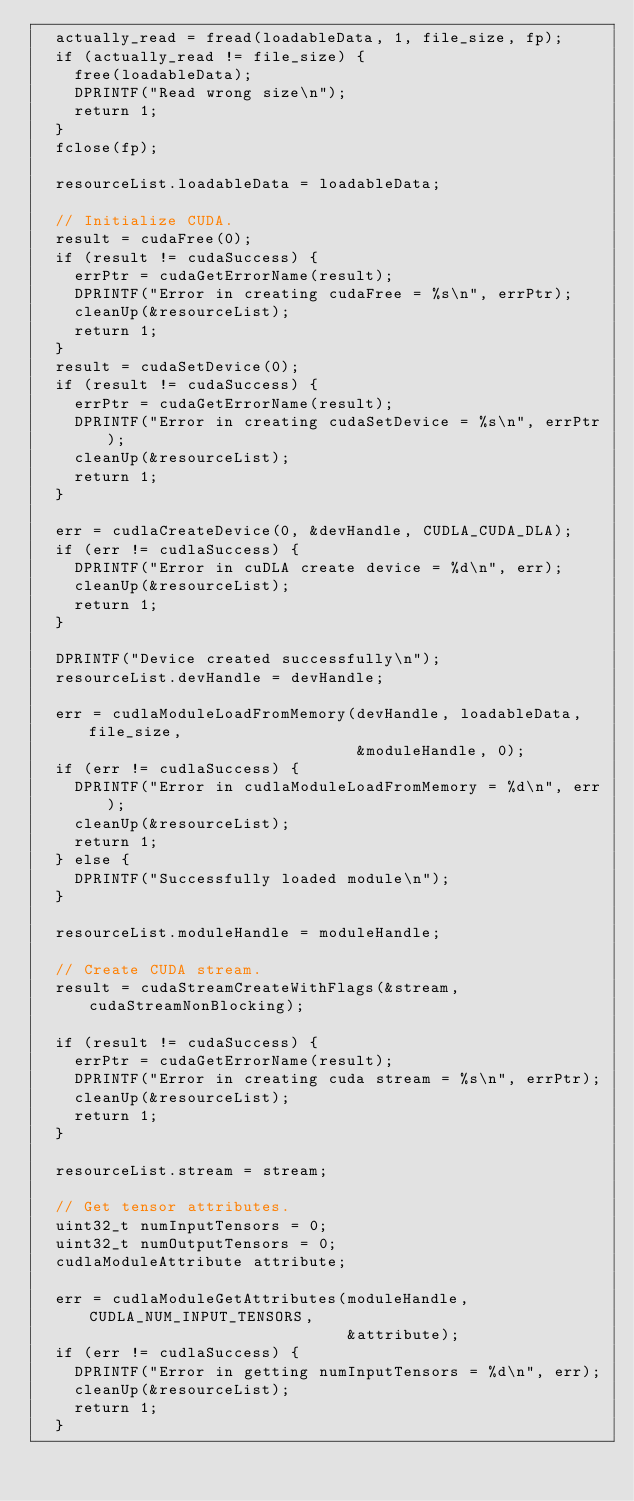<code> <loc_0><loc_0><loc_500><loc_500><_Cuda_>  actually_read = fread(loadableData, 1, file_size, fp);
  if (actually_read != file_size) {
    free(loadableData);
    DPRINTF("Read wrong size\n");
    return 1;
  }
  fclose(fp);

  resourceList.loadableData = loadableData;

  // Initialize CUDA.
  result = cudaFree(0);
  if (result != cudaSuccess) {
    errPtr = cudaGetErrorName(result);
    DPRINTF("Error in creating cudaFree = %s\n", errPtr);
    cleanUp(&resourceList);
    return 1;
  }
  result = cudaSetDevice(0);
  if (result != cudaSuccess) {
    errPtr = cudaGetErrorName(result);
    DPRINTF("Error in creating cudaSetDevice = %s\n", errPtr);
    cleanUp(&resourceList);
    return 1;
  }

  err = cudlaCreateDevice(0, &devHandle, CUDLA_CUDA_DLA);
  if (err != cudlaSuccess) {
    DPRINTF("Error in cuDLA create device = %d\n", err);
    cleanUp(&resourceList);
    return 1;
  }

  DPRINTF("Device created successfully\n");
  resourceList.devHandle = devHandle;

  err = cudlaModuleLoadFromMemory(devHandle, loadableData, file_size,
                                  &moduleHandle, 0);
  if (err != cudlaSuccess) {
    DPRINTF("Error in cudlaModuleLoadFromMemory = %d\n", err);
    cleanUp(&resourceList);
    return 1;
  } else {
    DPRINTF("Successfully loaded module\n");
  }

  resourceList.moduleHandle = moduleHandle;

  // Create CUDA stream.
  result = cudaStreamCreateWithFlags(&stream, cudaStreamNonBlocking);

  if (result != cudaSuccess) {
    errPtr = cudaGetErrorName(result);
    DPRINTF("Error in creating cuda stream = %s\n", errPtr);
    cleanUp(&resourceList);
    return 1;
  }

  resourceList.stream = stream;

  // Get tensor attributes.
  uint32_t numInputTensors = 0;
  uint32_t numOutputTensors = 0;
  cudlaModuleAttribute attribute;

  err = cudlaModuleGetAttributes(moduleHandle, CUDLA_NUM_INPUT_TENSORS,
                                 &attribute);
  if (err != cudlaSuccess) {
    DPRINTF("Error in getting numInputTensors = %d\n", err);
    cleanUp(&resourceList);
    return 1;
  }</code> 